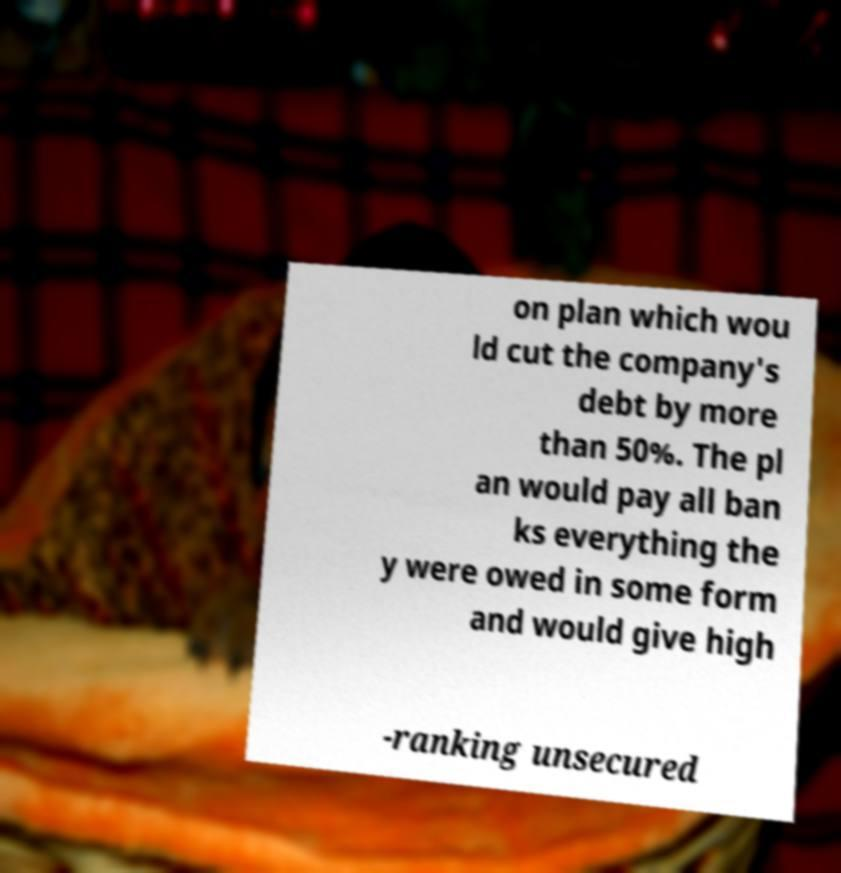Please read and relay the text visible in this image. What does it say? on plan which wou ld cut the company's debt by more than 50%. The pl an would pay all ban ks everything the y were owed in some form and would give high -ranking unsecured 